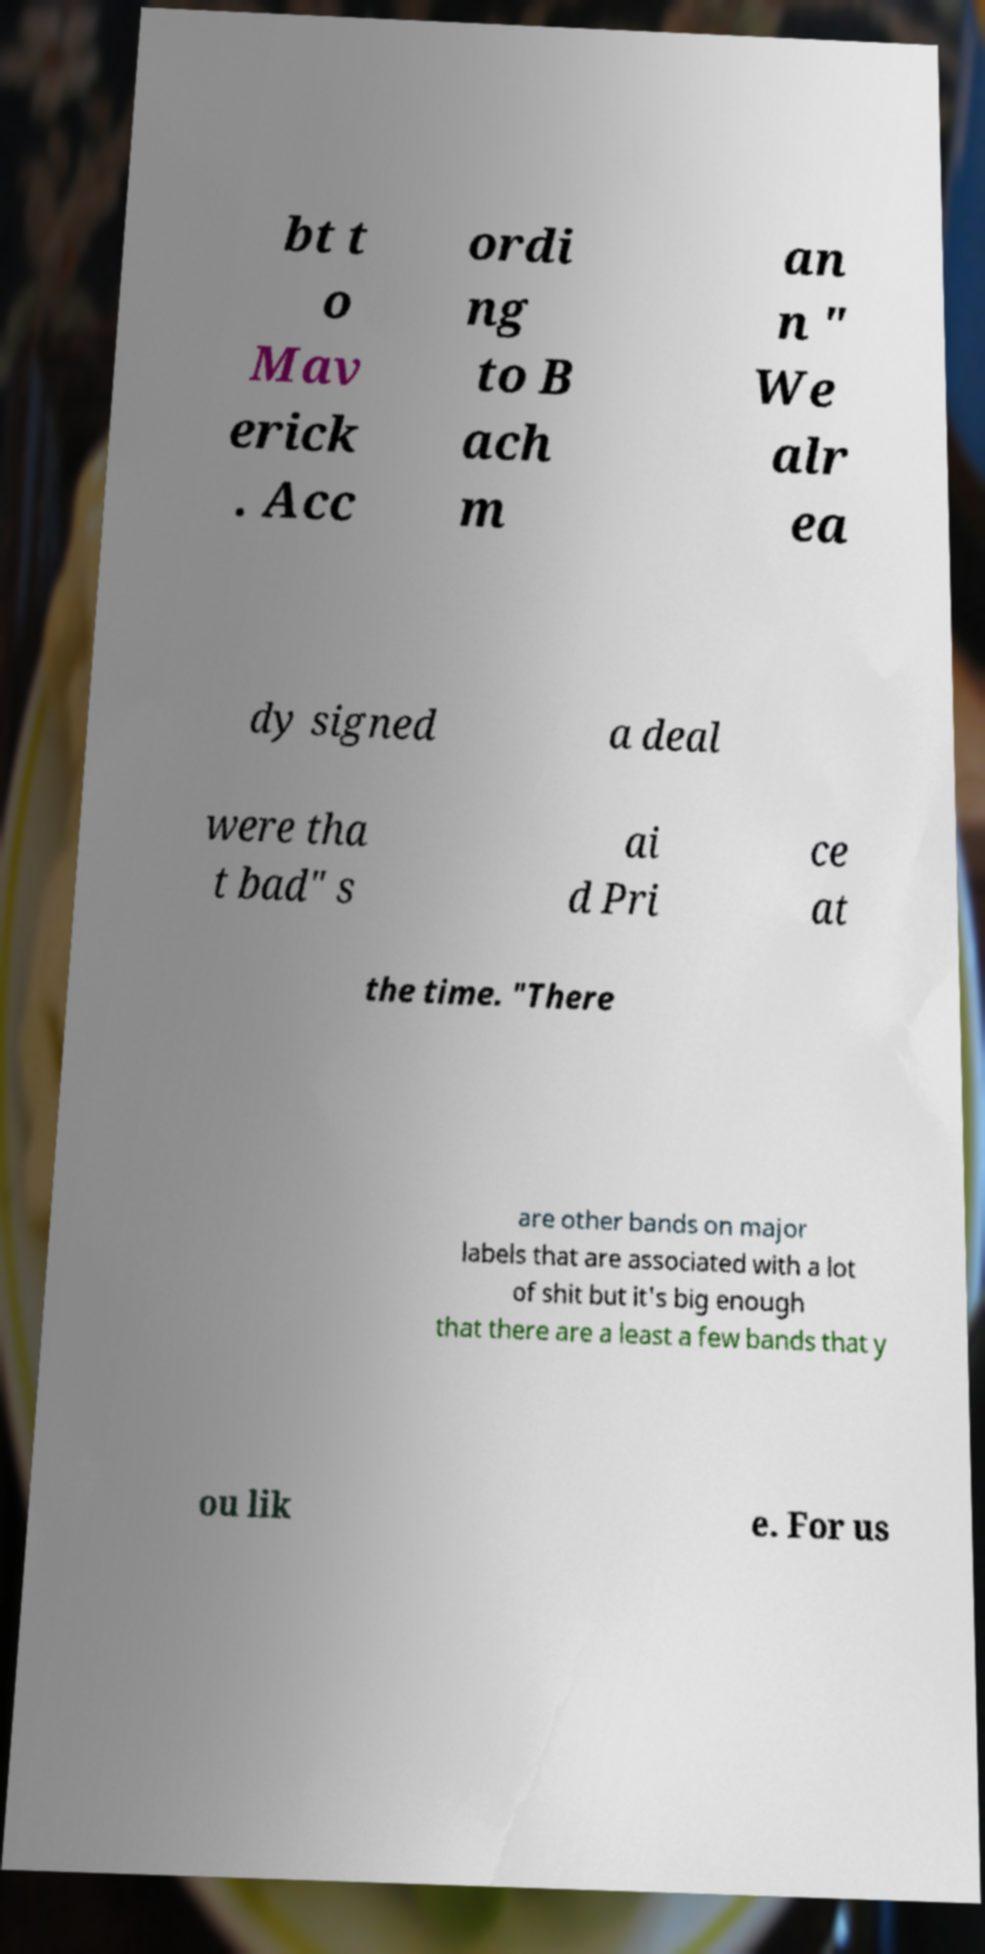Please identify and transcribe the text found in this image. bt t o Mav erick . Acc ordi ng to B ach m an n " We alr ea dy signed a deal were tha t bad" s ai d Pri ce at the time. "There are other bands on major labels that are associated with a lot of shit but it's big enough that there are a least a few bands that y ou lik e. For us 